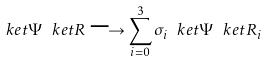Convert formula to latex. <formula><loc_0><loc_0><loc_500><loc_500>\ k e t { \Psi } \ k e t { R } \longrightarrow \sum _ { i = 0 } ^ { 3 } \sigma _ { i } \ k e t { \Psi } \ k e t { R _ { i } }</formula> 